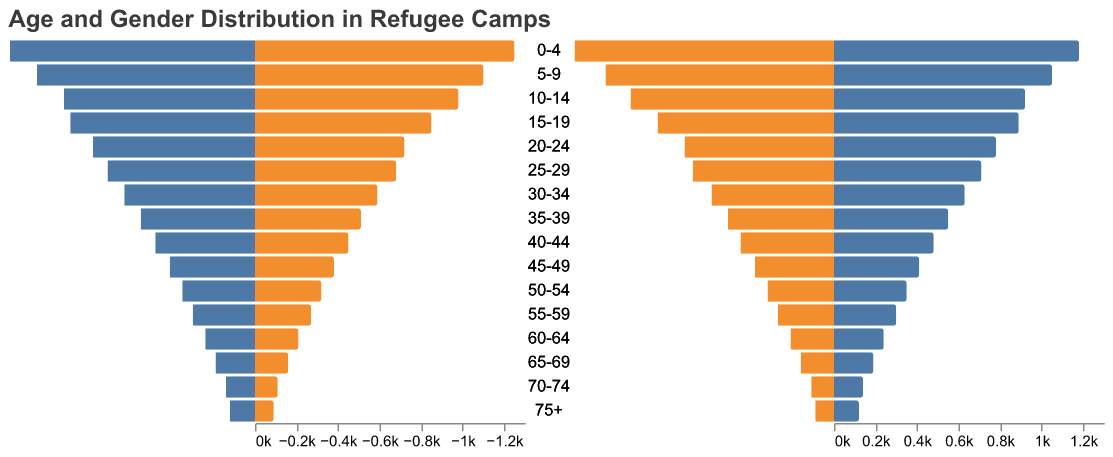what is the age group with the highest number of males? The bar for males is longest for the 0-4 age group. This indicates that the 0-4 age group has the highest number of males.
Answer: 0-4 which age group has more females than males? Comparing the sizes of the bars for males and females in each age group, females outnumber males in the 15-19 age group because the orange bar is longer there.
Answer: 15-19 what is the total number of people in the age group 10-14? The number of males in the 10-14 age group is 980 and the number of females is 920. Summing these, 980 + 920 = 1900.
Answer: 1900 how many more males are there in the 0-4 age group compared to females? The number of males in the 0-4 age group is 1250 and the number of females is 1180. The difference is 1250 - 1180 = 70.
Answer: 70 in which age group is the gender distribution closest to equal? The age groups 25-29 and 55-59 both show nearly equal bar lengths for males and females. By exact numbers, the 25-29 group has 680 males and 710 females, a difference of 30, which is very close.
Answer: 25-29 what is the total population of the 75+ age group? For the 75+ age group, males number 90 and females 120. Adding these gives 90 + 120 = 210.
Answer: 210 which gender has a larger population overall? Summing the populations, males: (1250+1100+980+850+720+680+590+510+450+380+320+270+210+160+110+90), totals to 8660 and females: (1180+1050+920+890+780+710+630+550+480+410+350+300+240+190+140+120), totals to 9230. Females have a larger overall population.
Answer: Females in which age group(s) are there less than 200 individuals for each gender? The 70-74 age group has 110 males and 140 females, and the 75+ age group has 90 males and 120 females. Both groups have less than 200 individuals each.
Answer: 75+ what is the overall population in the age group 40-44? The number of males in the 40-44 age group is 450 and the number of females is 480. Therefore, the total population is 450 + 480 = 930.
Answer: 930 